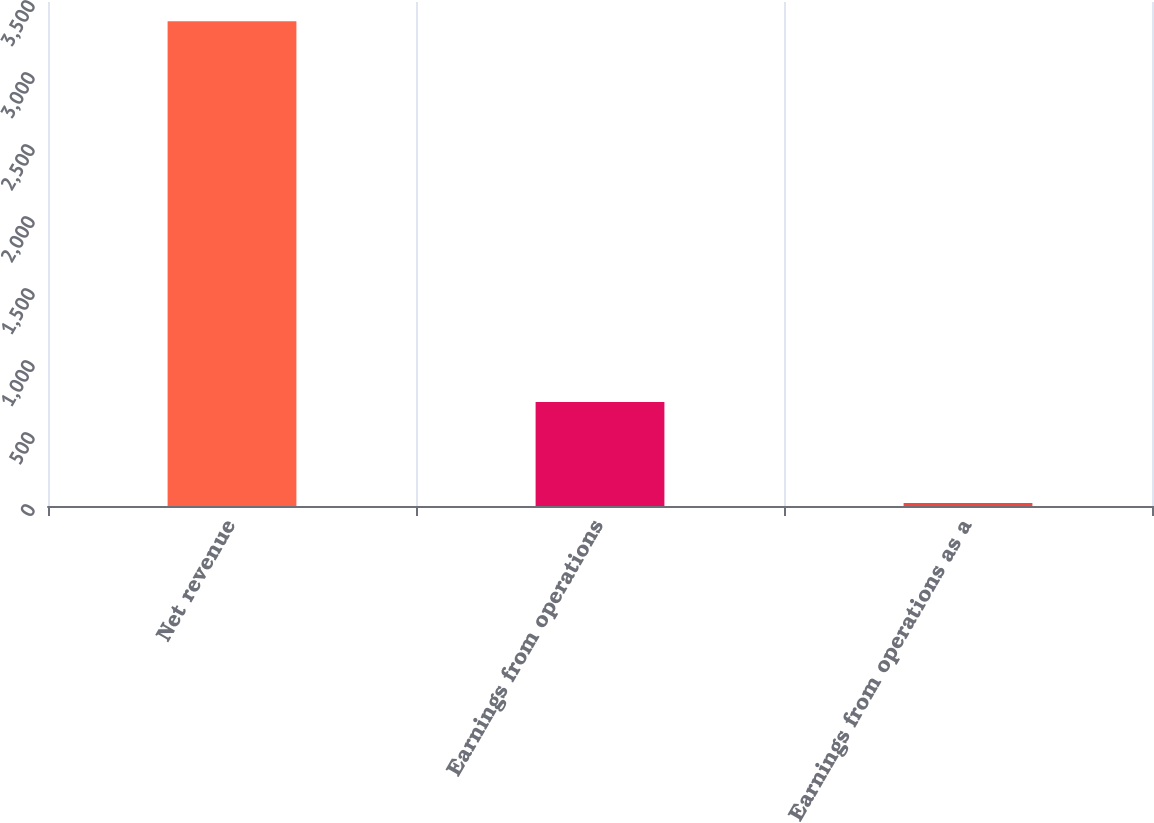<chart> <loc_0><loc_0><loc_500><loc_500><bar_chart><fcel>Net revenue<fcel>Earnings from operations<fcel>Earnings from operations as a<nl><fcel>3367<fcel>722<fcel>21.4<nl></chart> 